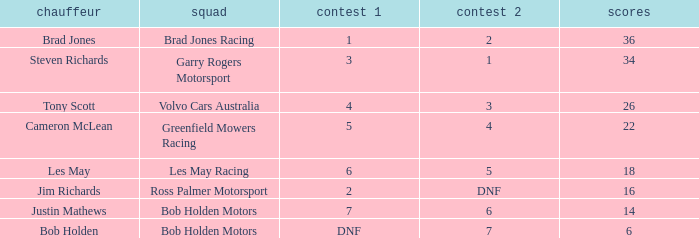Which driver for Bob Holden Motors has fewer than 36 points and placed 7 in race 1? Justin Mathews. 